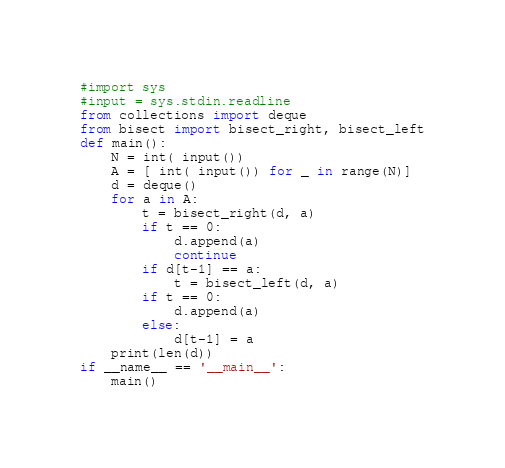<code> <loc_0><loc_0><loc_500><loc_500><_Python_>#import sys
#input = sys.stdin.readline
from collections import deque
from bisect import bisect_right, bisect_left
def main():
    N = int( input())
    A = [ int( input()) for _ in range(N)]
    d = deque()
    for a in A:
        t = bisect_right(d, a)
        if t == 0:
            d.append(a)
            continue
        if d[t-1] == a:
            t = bisect_left(d, a)
        if t == 0:
            d.append(a)
        else:
            d[t-1] = a
    print(len(d))
if __name__ == '__main__':
    main()
</code> 